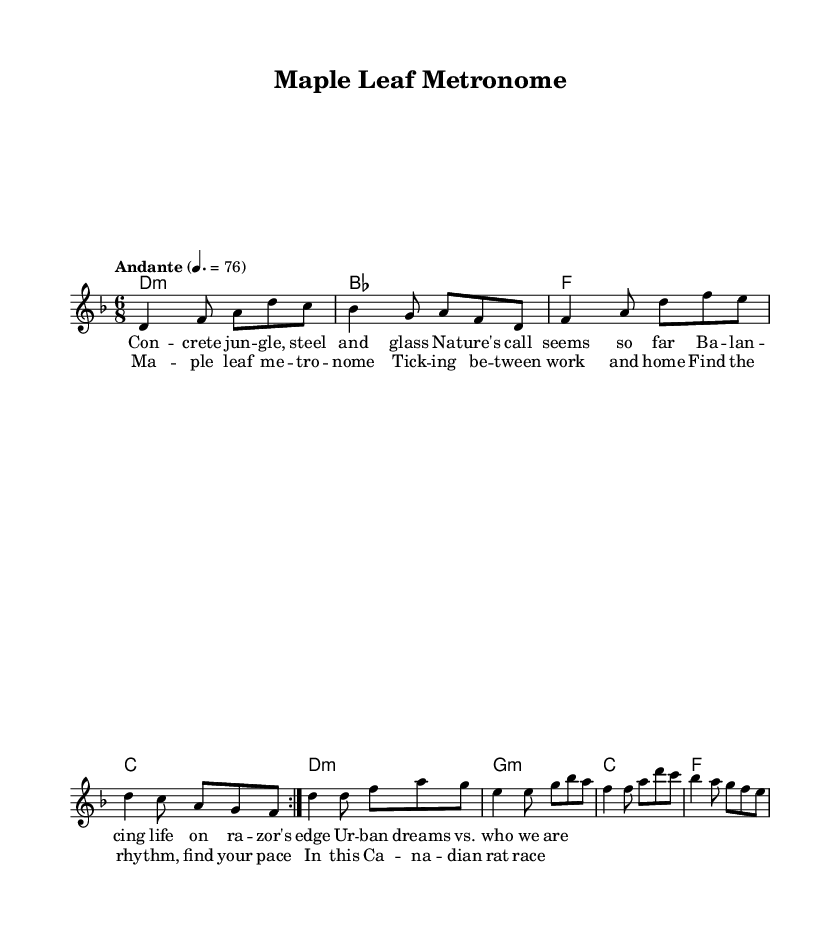What is the key signature of this music? The key signature is indicated at the beginning of the staff. Looking at the music, it shows a flat symbol indicating that the key is D minor, which has one flat (Bb).
Answer: D minor What is the time signature of this music? The time signature is visible at the beginning of the score, displayed as 6/8. This indicates that there are six beats in a measure, and the eighth note gets one beat.
Answer: 6/8 What is the tempo marking of this piece? The tempo is notated above the staff and reads "Andante" which typically suggests a moderately slow tempo. Additionally, there is a metronome indication of 76 beats per minute.
Answer: Andante How many measures are in the chorus? The chorus section is indicated in the lyrics, and by counting the lines of music that correspond to the chorus lyrics, there are four measures.
Answer: Four What is the first chord played in the harmony section? The first chord is situated at the beginning of the harmony line. By inspecting the chord notation, it is identified as a D minor chord.
Answer: D minor Which theme is referenced in the title of this piece? The title "Maple Leaf Metronome" suggests a connection to Canadian themes, particularly with the mention of "Maple Leaf," which is a national symbol of Canada. This reflects a theme relevant to the urban Canadian experience.
Answer: Canadian What is the poetic theme of the lyrics? Analyzing the lyrics, they address the contrasts between urban life and nature, challenges of work-life balance, and the daily grind of city living, consistent with folk-inspired metal themes.
Answer: Work-life balance 